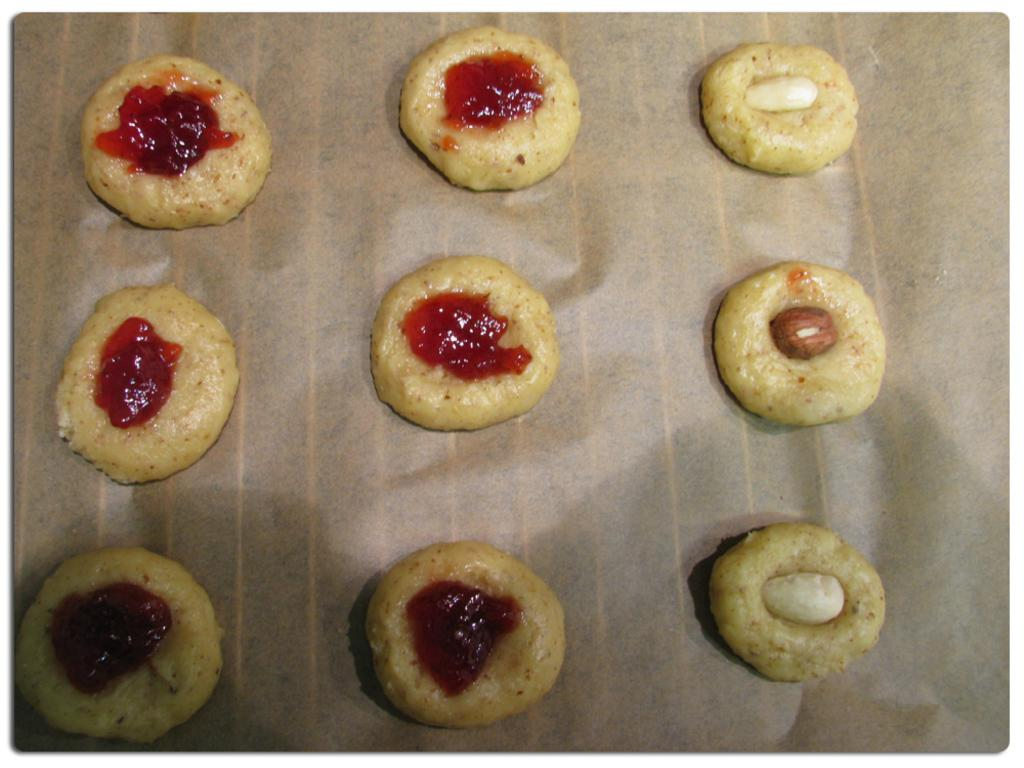What is present in the image? There are food items in the image. How are the food items arranged or presented? The food items are kept on a paper. What is the name of the daughter in the image? There is no daughter present in the image; it only features food items on a paper. 